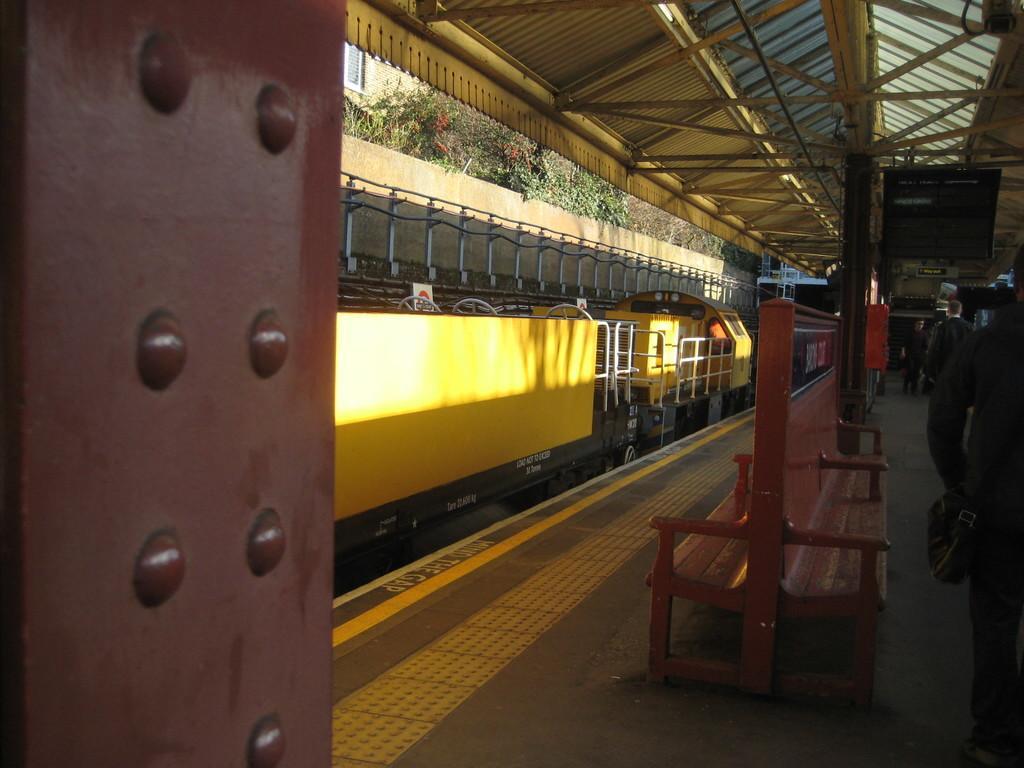Could you give a brief overview of what you see in this image? In the foreground I can see a train on the track, benches and group of people on the platform. At the top I can see a rooftop, trees and a building. This image is taken may be during a day. 